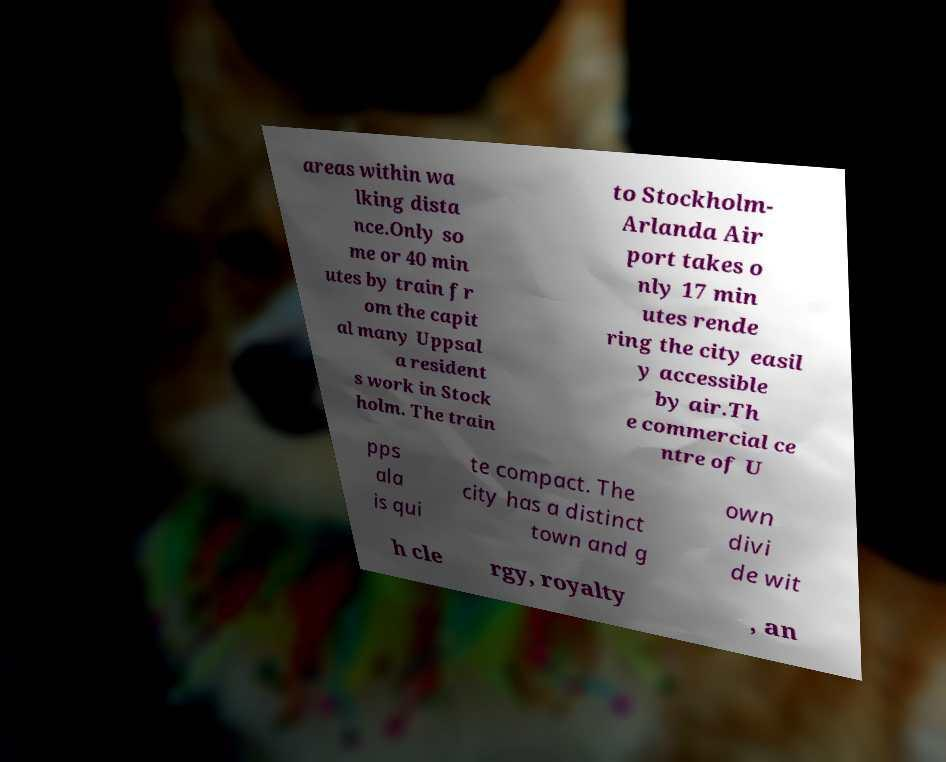Could you extract and type out the text from this image? areas within wa lking dista nce.Only so me or 40 min utes by train fr om the capit al many Uppsal a resident s work in Stock holm. The train to Stockholm- Arlanda Air port takes o nly 17 min utes rende ring the city easil y accessible by air.Th e commercial ce ntre of U pps ala is qui te compact. The city has a distinct town and g own divi de wit h cle rgy, royalty , an 